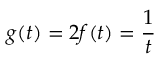<formula> <loc_0><loc_0><loc_500><loc_500>g ( t ) = 2 f ( t ) = \frac { 1 } { t }</formula> 